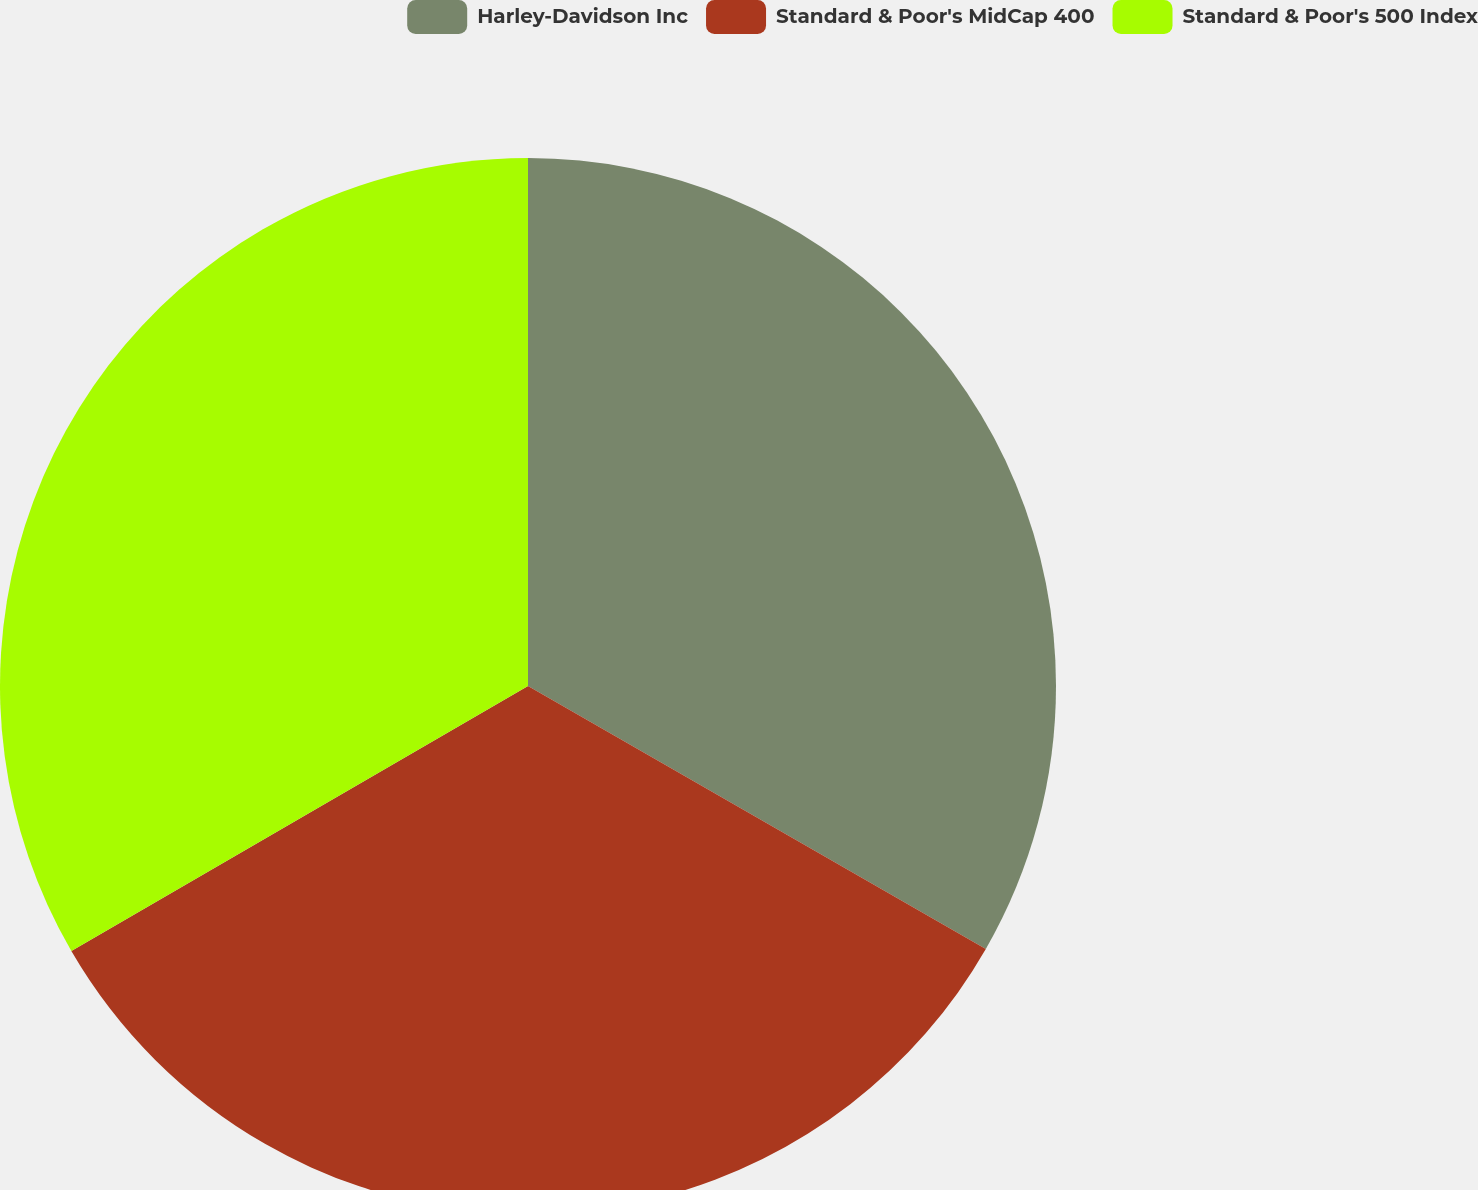Convert chart to OTSL. <chart><loc_0><loc_0><loc_500><loc_500><pie_chart><fcel>Harley-Davidson Inc<fcel>Standard & Poor's MidCap 400<fcel>Standard & Poor's 500 Index<nl><fcel>33.3%<fcel>33.33%<fcel>33.37%<nl></chart> 